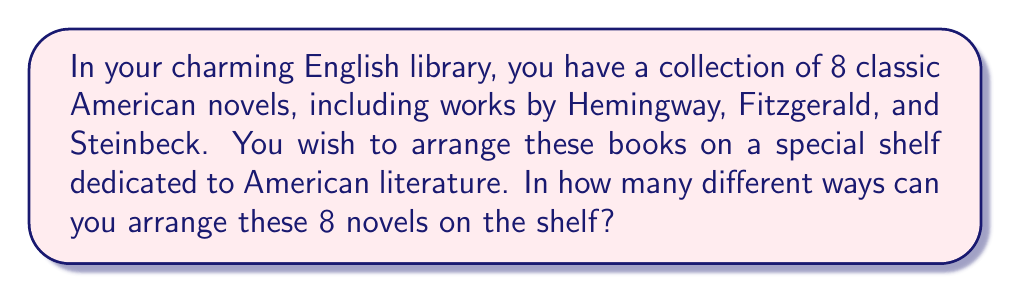Help me with this question. To solve this problem, we need to consider the concept of permutations in discrete mathematics. A permutation is an arrangement of objects where order matters.

In this case:
1. We have 8 distinct books.
2. All 8 books will be used in each arrangement.
3. The order of the books matters (as they are being arranged on a shelf).

This scenario is a perfect example of a permutation without repetition. The formula for such a permutation is:

$$P(n) = n!$$

Where $n$ is the number of distinct objects (in this case, books).

For our problem:
$$P(8) = 8!$$

Let's calculate this step-by-step:

$$\begin{align}
8! &= 8 \times 7 \times 6 \times 5 \times 4 \times 3 \times 2 \times 1 \\
&= 40,320
\end{align}$$

Therefore, there are 40,320 different ways to arrange the 8 classic American novels on your shelf.

This large number illustrates the vast possibilities that exist even with a relatively small collection of books, much like the vast possibilities explored within the pages of these classic American novels.
Answer: $40,320$ ways 